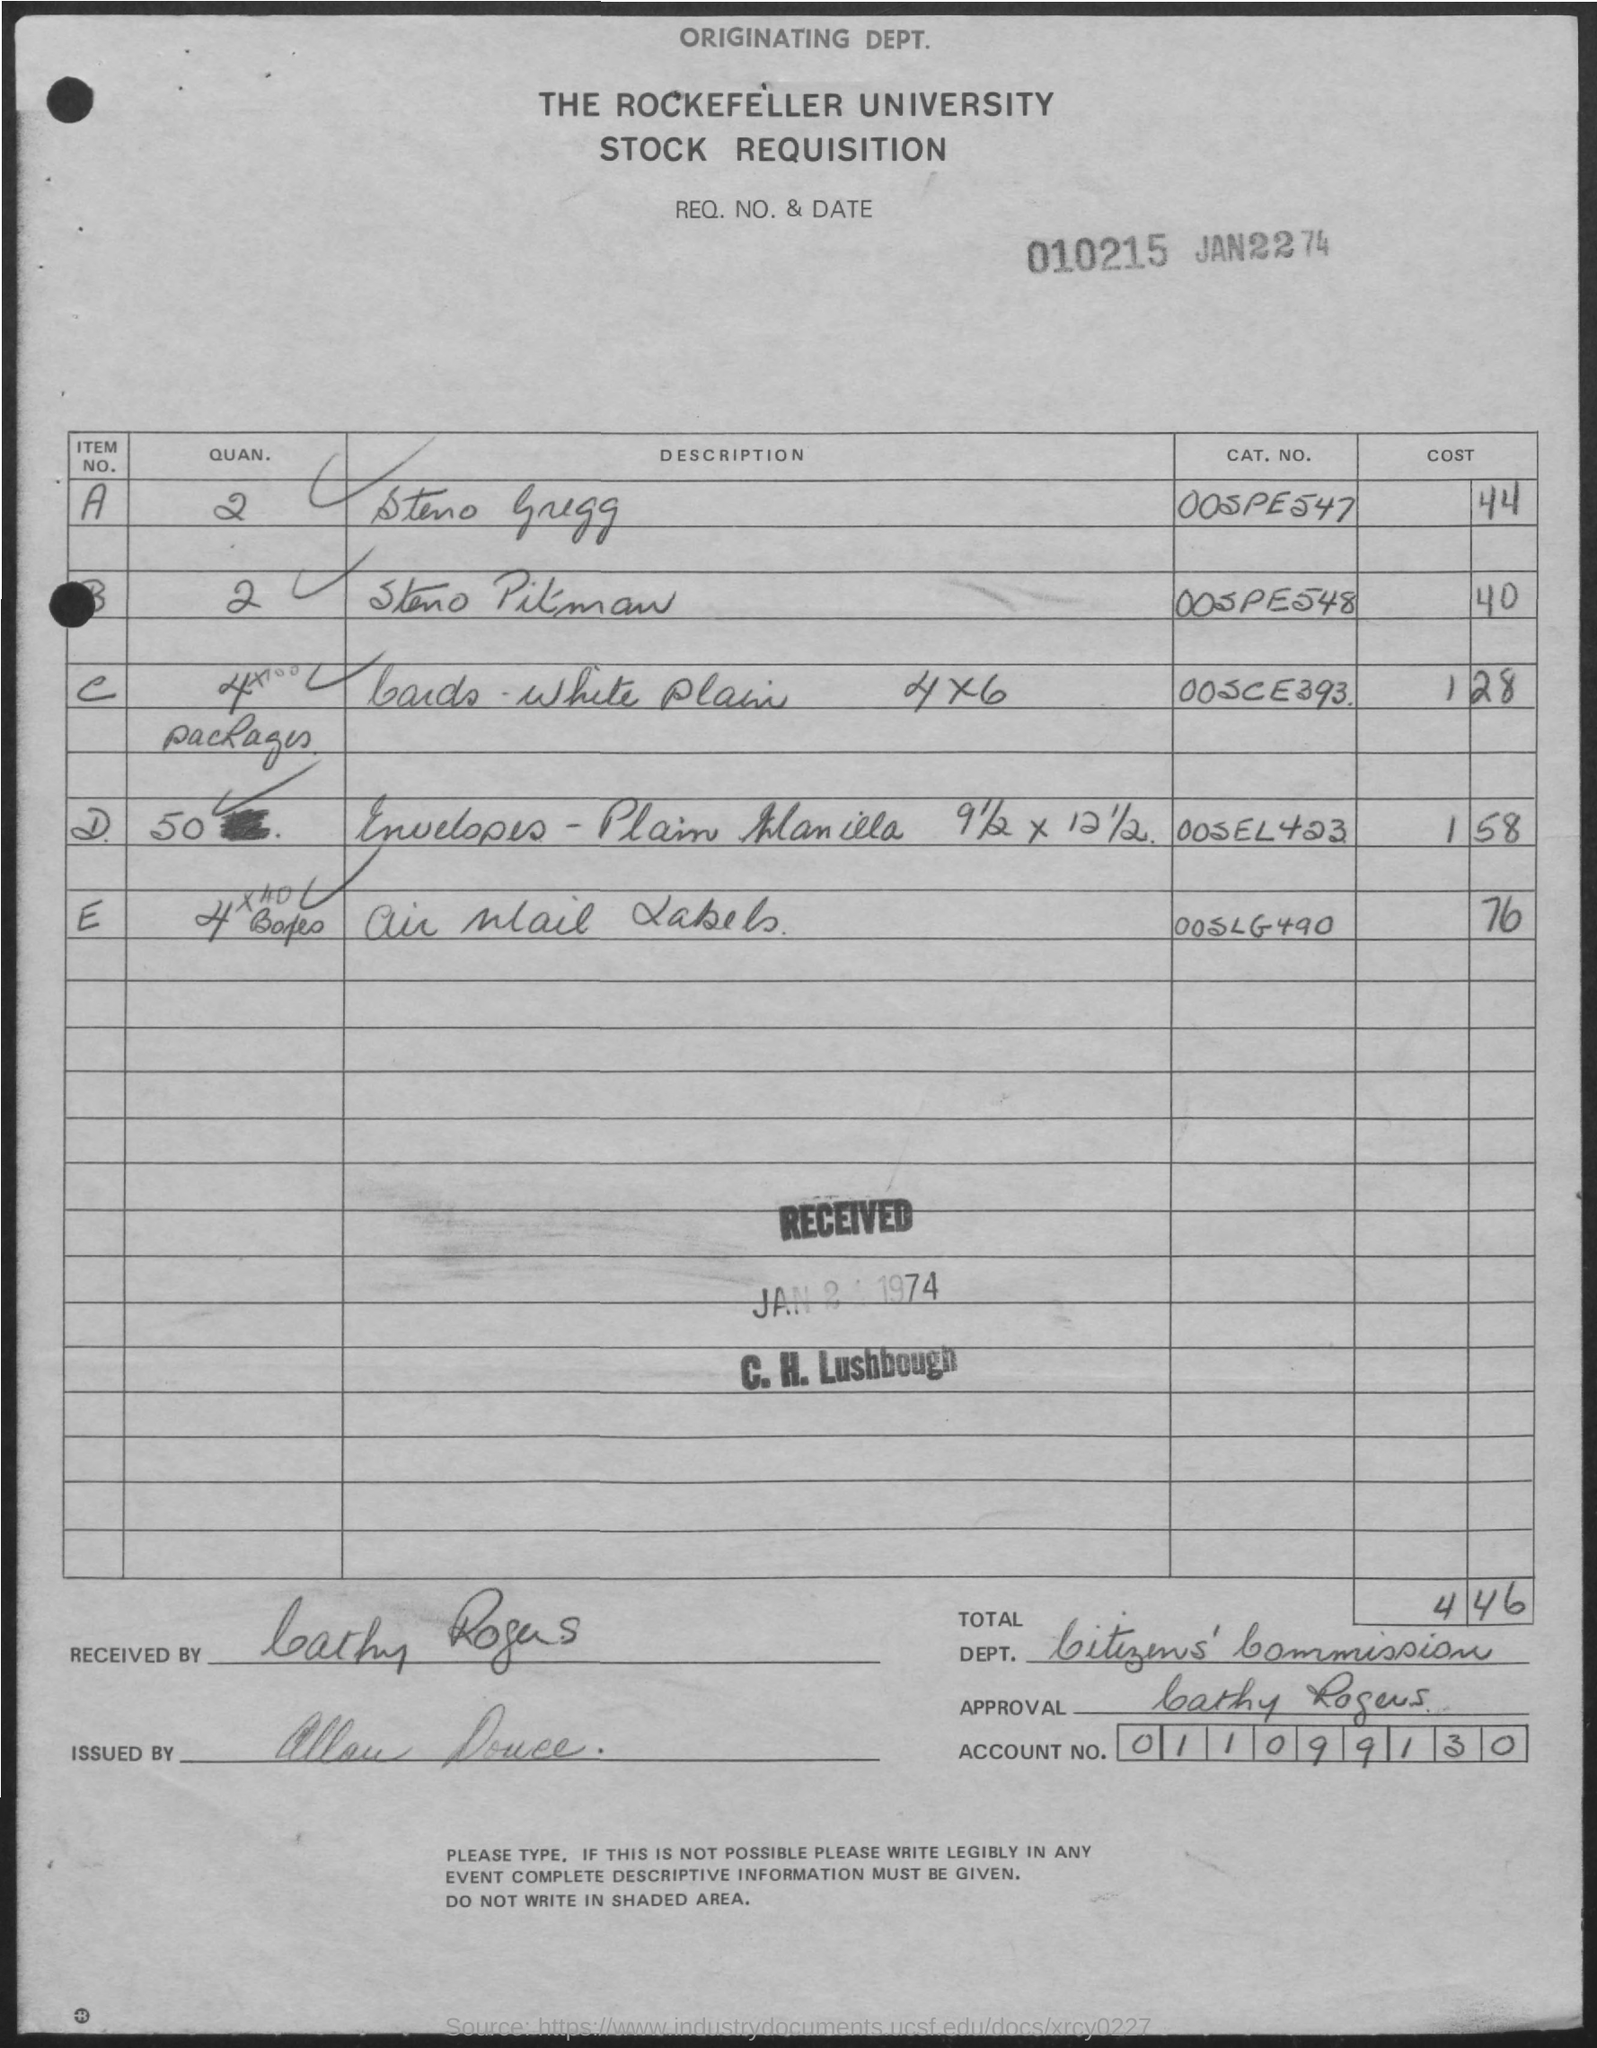Whats the quantity of Envelopes?
Keep it short and to the point. 50. Mention the cost of Steri Pitman?
Offer a terse response. 40. Whats the TOTAL cost of the items requested?
Offer a very short reply. 4.46. Whats the Account No. mentioned?
Make the answer very short. 011099130. 